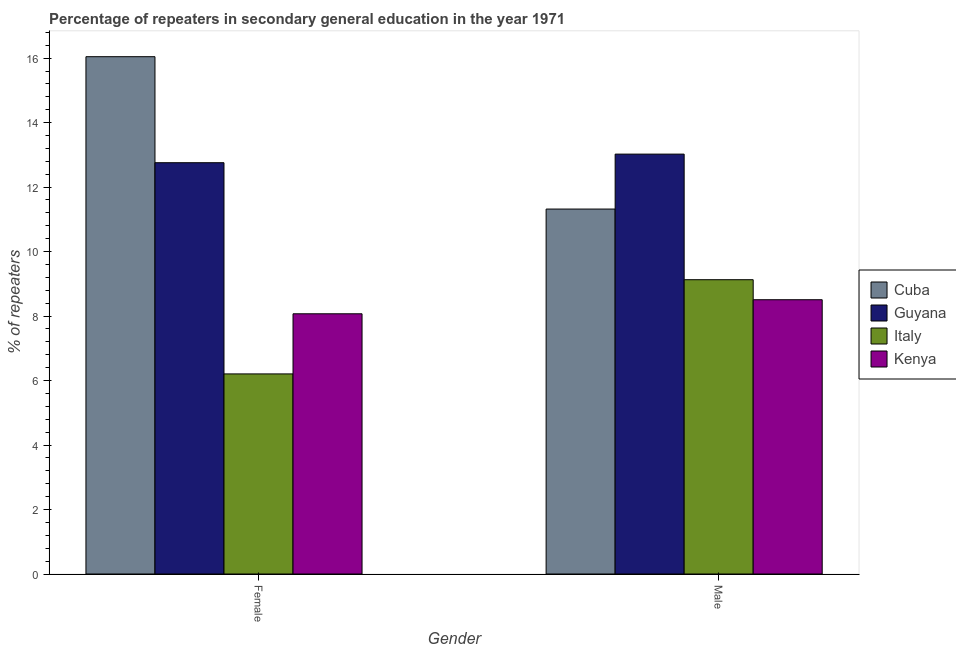How many different coloured bars are there?
Keep it short and to the point. 4. How many groups of bars are there?
Your response must be concise. 2. Are the number of bars per tick equal to the number of legend labels?
Your answer should be compact. Yes. Are the number of bars on each tick of the X-axis equal?
Keep it short and to the point. Yes. How many bars are there on the 2nd tick from the right?
Provide a succinct answer. 4. What is the label of the 1st group of bars from the left?
Ensure brevity in your answer.  Female. What is the percentage of male repeaters in Kenya?
Your response must be concise. 8.51. Across all countries, what is the maximum percentage of female repeaters?
Provide a succinct answer. 16.04. Across all countries, what is the minimum percentage of male repeaters?
Provide a succinct answer. 8.51. In which country was the percentage of female repeaters maximum?
Make the answer very short. Cuba. In which country was the percentage of male repeaters minimum?
Offer a terse response. Kenya. What is the total percentage of female repeaters in the graph?
Keep it short and to the point. 43.08. What is the difference between the percentage of male repeaters in Guyana and that in Italy?
Provide a succinct answer. 3.9. What is the difference between the percentage of female repeaters in Italy and the percentage of male repeaters in Cuba?
Offer a very short reply. -5.11. What is the average percentage of male repeaters per country?
Your response must be concise. 10.49. What is the difference between the percentage of male repeaters and percentage of female repeaters in Italy?
Make the answer very short. 2.92. In how many countries, is the percentage of female repeaters greater than 7.6 %?
Offer a terse response. 3. What is the ratio of the percentage of female repeaters in Kenya to that in Cuba?
Offer a very short reply. 0.5. Is the percentage of female repeaters in Guyana less than that in Kenya?
Provide a short and direct response. No. What does the 2nd bar from the left in Male represents?
Your answer should be very brief. Guyana. What does the 1st bar from the right in Female represents?
Provide a short and direct response. Kenya. How many bars are there?
Your answer should be very brief. 8. How many countries are there in the graph?
Your answer should be very brief. 4. What is the difference between two consecutive major ticks on the Y-axis?
Your response must be concise. 2. Are the values on the major ticks of Y-axis written in scientific E-notation?
Give a very brief answer. No. How many legend labels are there?
Your answer should be compact. 4. What is the title of the graph?
Make the answer very short. Percentage of repeaters in secondary general education in the year 1971. Does "Croatia" appear as one of the legend labels in the graph?
Give a very brief answer. No. What is the label or title of the Y-axis?
Keep it short and to the point. % of repeaters. What is the % of repeaters in Cuba in Female?
Provide a short and direct response. 16.04. What is the % of repeaters of Guyana in Female?
Your answer should be very brief. 12.76. What is the % of repeaters of Italy in Female?
Provide a succinct answer. 6.21. What is the % of repeaters of Kenya in Female?
Ensure brevity in your answer.  8.07. What is the % of repeaters of Cuba in Male?
Your answer should be compact. 11.32. What is the % of repeaters of Guyana in Male?
Ensure brevity in your answer.  13.02. What is the % of repeaters of Italy in Male?
Provide a succinct answer. 9.13. What is the % of repeaters of Kenya in Male?
Give a very brief answer. 8.51. Across all Gender, what is the maximum % of repeaters in Cuba?
Provide a succinct answer. 16.04. Across all Gender, what is the maximum % of repeaters in Guyana?
Provide a succinct answer. 13.02. Across all Gender, what is the maximum % of repeaters in Italy?
Offer a very short reply. 9.13. Across all Gender, what is the maximum % of repeaters in Kenya?
Offer a terse response. 8.51. Across all Gender, what is the minimum % of repeaters in Cuba?
Offer a terse response. 11.32. Across all Gender, what is the minimum % of repeaters of Guyana?
Your answer should be very brief. 12.76. Across all Gender, what is the minimum % of repeaters in Italy?
Ensure brevity in your answer.  6.21. Across all Gender, what is the minimum % of repeaters of Kenya?
Your response must be concise. 8.07. What is the total % of repeaters in Cuba in the graph?
Your response must be concise. 27.36. What is the total % of repeaters in Guyana in the graph?
Offer a terse response. 25.78. What is the total % of repeaters of Italy in the graph?
Provide a short and direct response. 15.33. What is the total % of repeaters of Kenya in the graph?
Ensure brevity in your answer.  16.58. What is the difference between the % of repeaters in Cuba in Female and that in Male?
Offer a very short reply. 4.73. What is the difference between the % of repeaters in Guyana in Female and that in Male?
Offer a terse response. -0.27. What is the difference between the % of repeaters in Italy in Female and that in Male?
Offer a very short reply. -2.92. What is the difference between the % of repeaters of Kenya in Female and that in Male?
Offer a terse response. -0.44. What is the difference between the % of repeaters in Cuba in Female and the % of repeaters in Guyana in Male?
Give a very brief answer. 3.02. What is the difference between the % of repeaters of Cuba in Female and the % of repeaters of Italy in Male?
Your answer should be compact. 6.92. What is the difference between the % of repeaters in Cuba in Female and the % of repeaters in Kenya in Male?
Your response must be concise. 7.54. What is the difference between the % of repeaters of Guyana in Female and the % of repeaters of Italy in Male?
Keep it short and to the point. 3.63. What is the difference between the % of repeaters in Guyana in Female and the % of repeaters in Kenya in Male?
Keep it short and to the point. 4.25. What is the difference between the % of repeaters in Italy in Female and the % of repeaters in Kenya in Male?
Offer a very short reply. -2.3. What is the average % of repeaters in Cuba per Gender?
Provide a short and direct response. 13.68. What is the average % of repeaters of Guyana per Gender?
Provide a short and direct response. 12.89. What is the average % of repeaters of Italy per Gender?
Keep it short and to the point. 7.67. What is the average % of repeaters of Kenya per Gender?
Your answer should be very brief. 8.29. What is the difference between the % of repeaters of Cuba and % of repeaters of Guyana in Female?
Your answer should be compact. 3.29. What is the difference between the % of repeaters in Cuba and % of repeaters in Italy in Female?
Provide a succinct answer. 9.84. What is the difference between the % of repeaters of Cuba and % of repeaters of Kenya in Female?
Your answer should be very brief. 7.97. What is the difference between the % of repeaters in Guyana and % of repeaters in Italy in Female?
Provide a short and direct response. 6.55. What is the difference between the % of repeaters in Guyana and % of repeaters in Kenya in Female?
Provide a succinct answer. 4.69. What is the difference between the % of repeaters of Italy and % of repeaters of Kenya in Female?
Your answer should be compact. -1.86. What is the difference between the % of repeaters of Cuba and % of repeaters of Guyana in Male?
Your response must be concise. -1.7. What is the difference between the % of repeaters in Cuba and % of repeaters in Italy in Male?
Your answer should be very brief. 2.19. What is the difference between the % of repeaters in Cuba and % of repeaters in Kenya in Male?
Your answer should be very brief. 2.81. What is the difference between the % of repeaters in Guyana and % of repeaters in Italy in Male?
Make the answer very short. 3.9. What is the difference between the % of repeaters in Guyana and % of repeaters in Kenya in Male?
Give a very brief answer. 4.52. What is the difference between the % of repeaters of Italy and % of repeaters of Kenya in Male?
Provide a short and direct response. 0.62. What is the ratio of the % of repeaters in Cuba in Female to that in Male?
Your answer should be compact. 1.42. What is the ratio of the % of repeaters of Guyana in Female to that in Male?
Give a very brief answer. 0.98. What is the ratio of the % of repeaters in Italy in Female to that in Male?
Give a very brief answer. 0.68. What is the ratio of the % of repeaters in Kenya in Female to that in Male?
Offer a terse response. 0.95. What is the difference between the highest and the second highest % of repeaters of Cuba?
Your answer should be compact. 4.73. What is the difference between the highest and the second highest % of repeaters of Guyana?
Offer a terse response. 0.27. What is the difference between the highest and the second highest % of repeaters in Italy?
Your response must be concise. 2.92. What is the difference between the highest and the second highest % of repeaters of Kenya?
Keep it short and to the point. 0.44. What is the difference between the highest and the lowest % of repeaters of Cuba?
Keep it short and to the point. 4.73. What is the difference between the highest and the lowest % of repeaters in Guyana?
Offer a very short reply. 0.27. What is the difference between the highest and the lowest % of repeaters in Italy?
Provide a short and direct response. 2.92. What is the difference between the highest and the lowest % of repeaters of Kenya?
Make the answer very short. 0.44. 